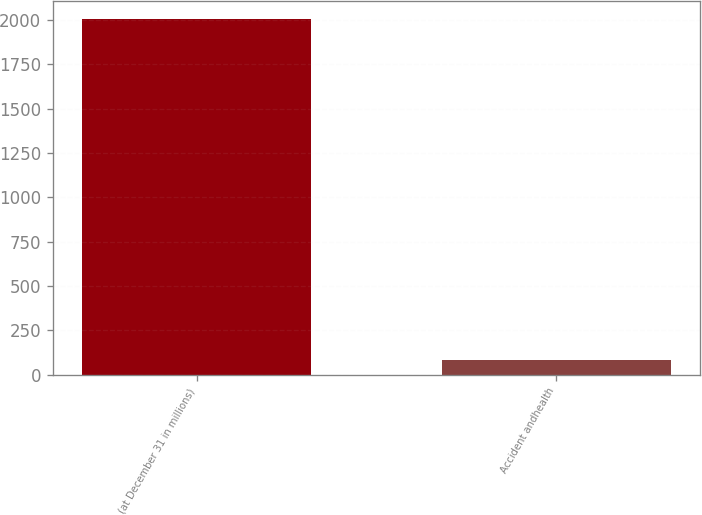Convert chart to OTSL. <chart><loc_0><loc_0><loc_500><loc_500><bar_chart><fcel>(at December 31 in millions)<fcel>Accident andhealth<nl><fcel>2005<fcel>83<nl></chart> 